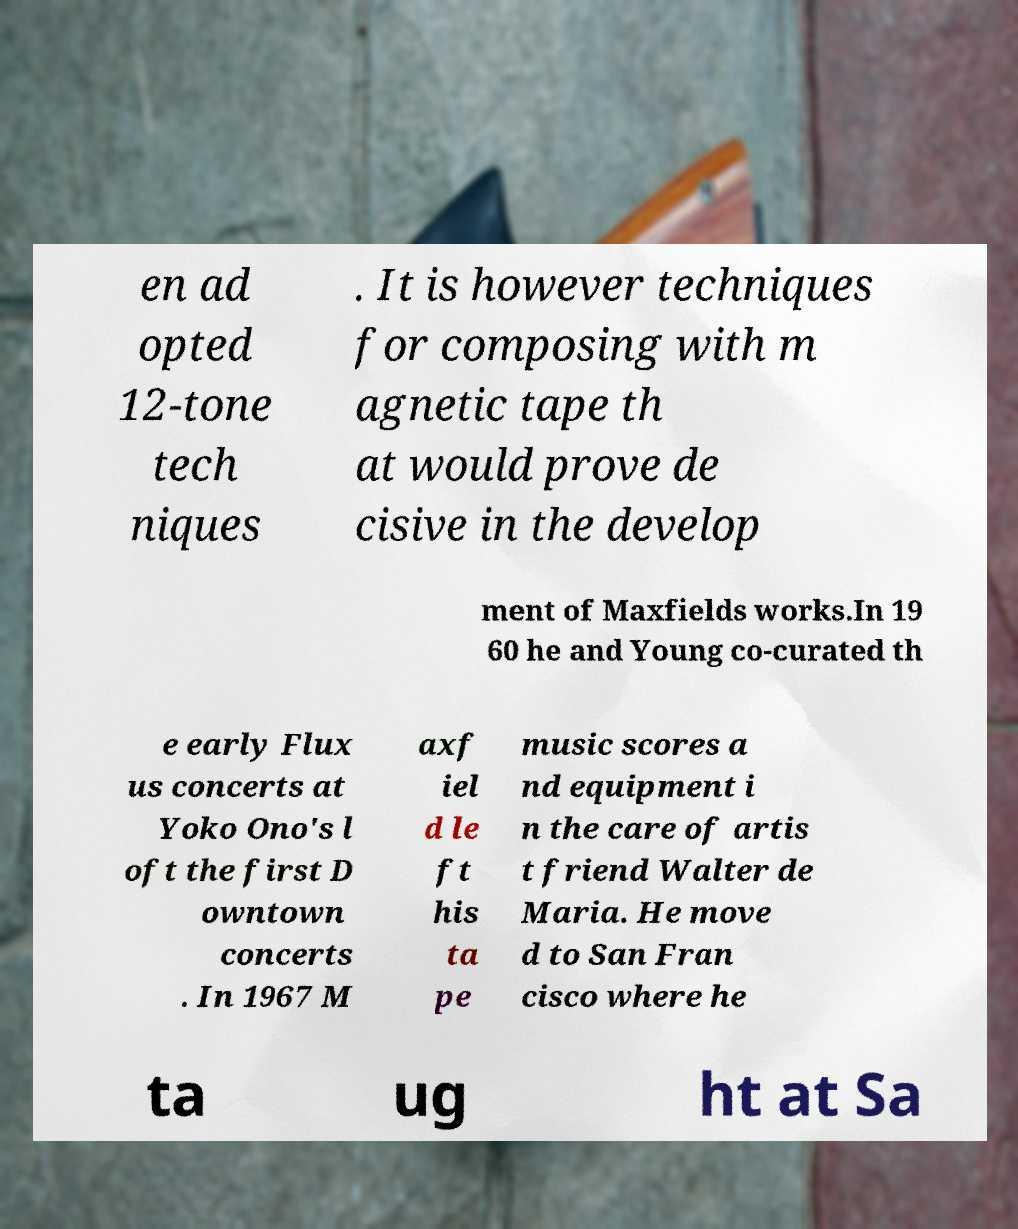Please identify and transcribe the text found in this image. en ad opted 12-tone tech niques . It is however techniques for composing with m agnetic tape th at would prove de cisive in the develop ment of Maxfields works.In 19 60 he and Young co-curated th e early Flux us concerts at Yoko Ono's l oft the first D owntown concerts . In 1967 M axf iel d le ft his ta pe music scores a nd equipment i n the care of artis t friend Walter de Maria. He move d to San Fran cisco where he ta ug ht at Sa 